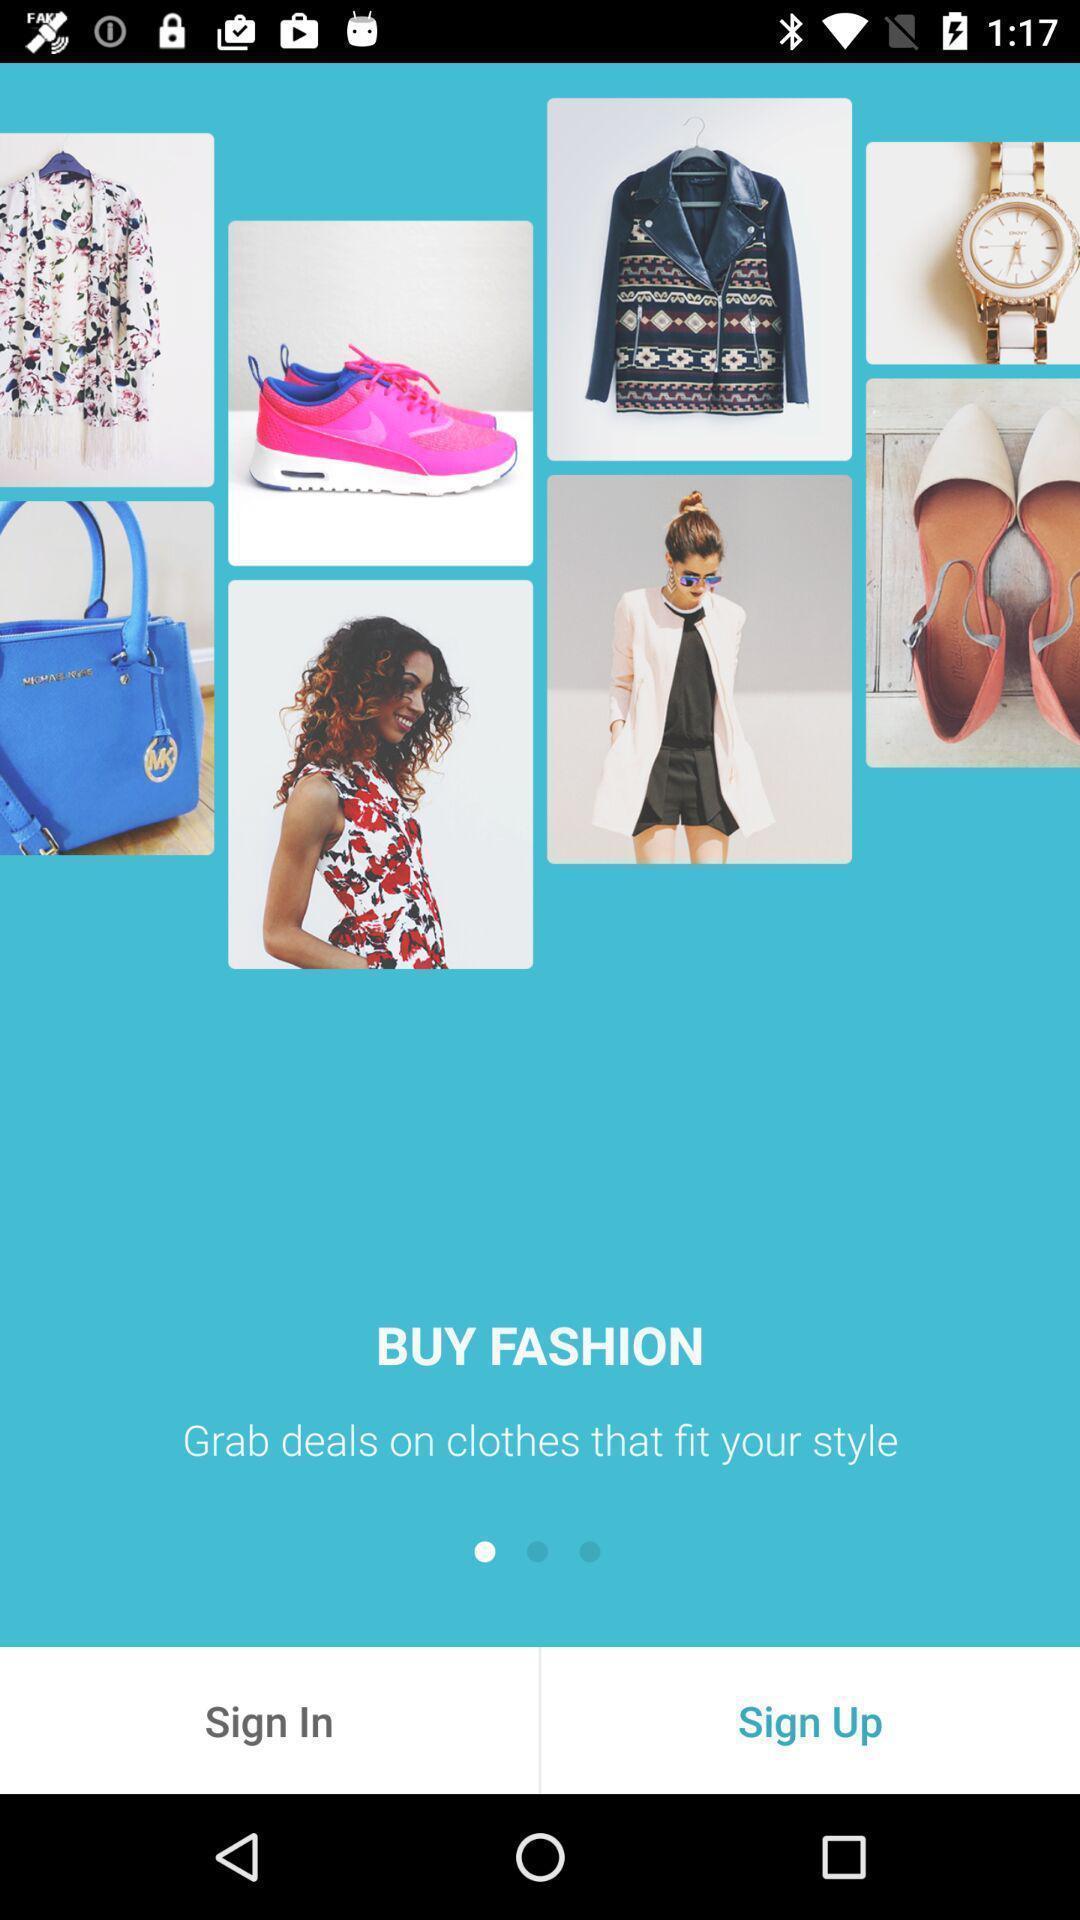Provide a description of this screenshot. Welcome to the sign in page. 